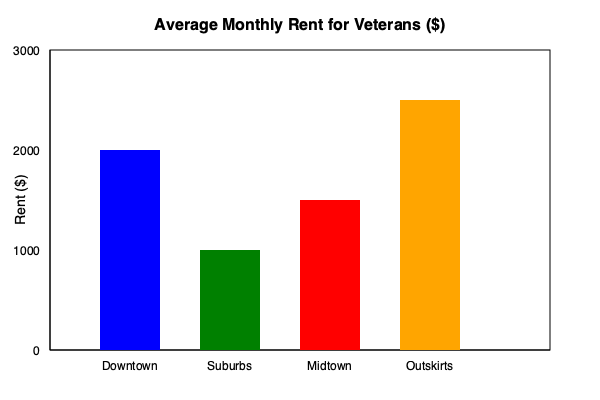Based on the bar graph showing average monthly rent for veterans in different neighborhoods, which area offers the most affordable housing option, and how much could a veteran potentially save annually by choosing this neighborhood over the most expensive one? To answer this question, we need to follow these steps:

1. Identify the most affordable and most expensive neighborhoods:
   - Downtown: $2000
   - Suburbs: $1000
   - Midtown: $1500
   - Outskirts: $2500

   The most affordable is Suburbs at $1000/month.
   The most expensive is Outskirts at $2500/month.

2. Calculate the monthly difference in rent:
   $2500 - $1000 = $1500 per month

3. Calculate the annual savings:
   $1500 × 12 months = $18,000 per year

Therefore, a veteran could potentially save $18,000 annually by choosing to live in the Suburbs instead of the Outskirts.

This information is crucial for a local government representative seeking to understand and address housing affordability issues for veterans. It highlights the significant impact that location choice can have on a veteran's financial situation and could inform policies aimed at improving housing options or providing targeted assistance in certain areas.
Answer: Suburbs; $18,000 annually 